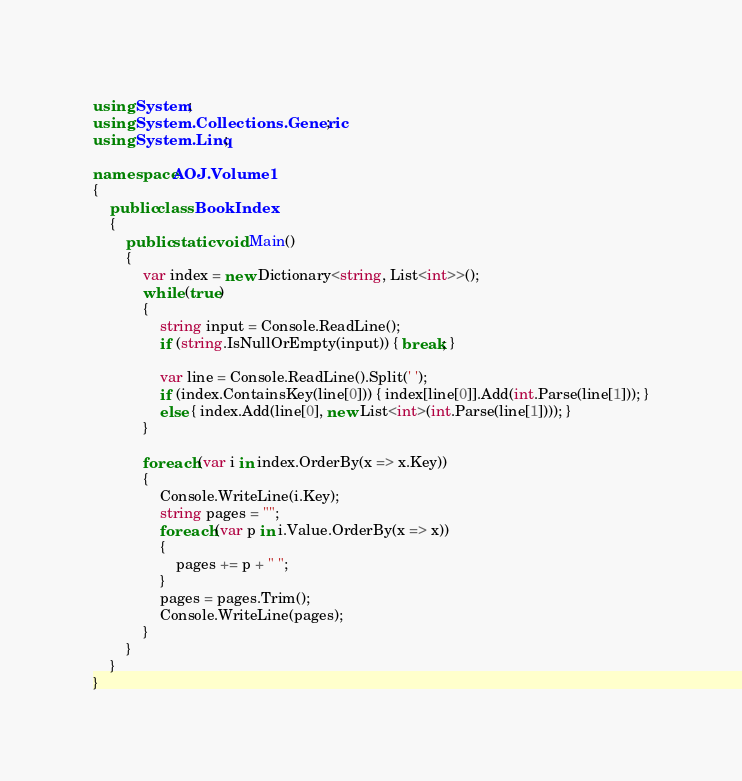Convert code to text. <code><loc_0><loc_0><loc_500><loc_500><_C#_>using System;
using System.Collections.Generic;
using System.Linq;

namespace AOJ.Volume1
{
    public class BookIndex
    {
        public static void Main()
        {
            var index = new Dictionary<string, List<int>>();
            while (true)
            {
                string input = Console.ReadLine();
                if (string.IsNullOrEmpty(input)) { break; }

                var line = Console.ReadLine().Split(' ');
                if (index.ContainsKey(line[0])) { index[line[0]].Add(int.Parse(line[1])); }
                else { index.Add(line[0], new List<int>(int.Parse(line[1]))); }
            }

            foreach (var i in index.OrderBy(x => x.Key))
            {
                Console.WriteLine(i.Key);
                string pages = "";
                foreach (var p in i.Value.OrderBy(x => x))
                {
                    pages += p + " ";
                }
                pages = pages.Trim();
                Console.WriteLine(pages);
            }
        }
    }
}</code> 